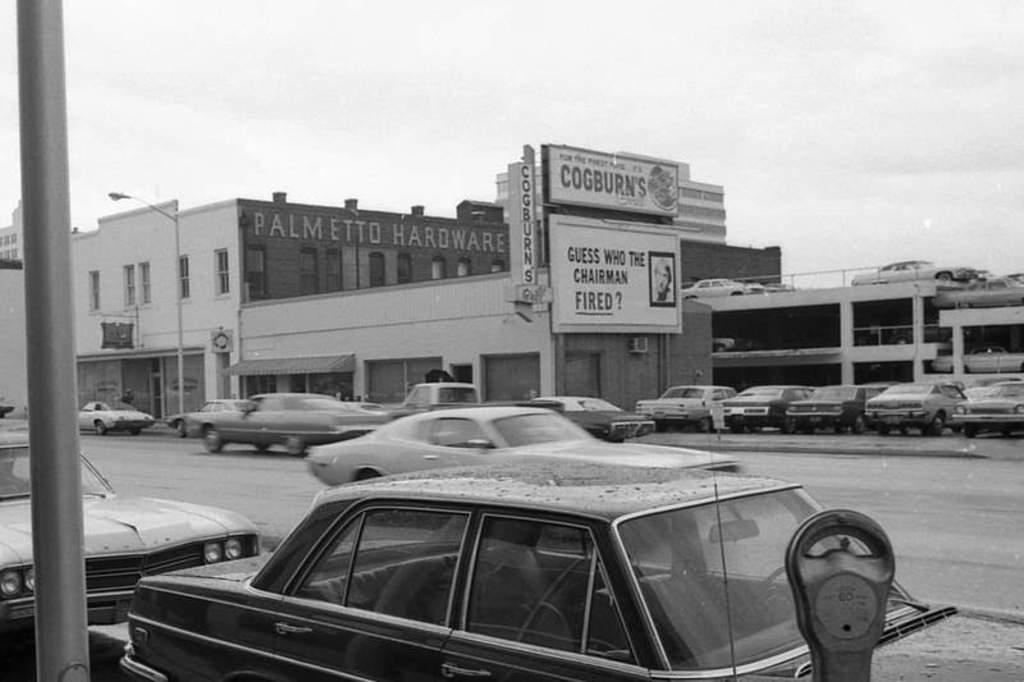What is happening on the road in the image? There are cars moving on the road in the image. Where are some cars located in the image? Some cars are parked in the parking lot on the right side of the image. What can be seen in the background of the image? There is a building and the sky visible in the background of the image. What type of machine is being used to make pickles in the image? There is no machine or pickles present in the image; it features cars moving on the road and parked in a parking lot, with a building and the sky visible in the background. 